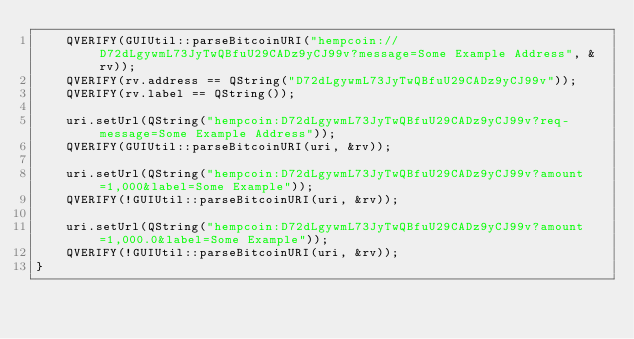Convert code to text. <code><loc_0><loc_0><loc_500><loc_500><_C++_>    QVERIFY(GUIUtil::parseBitcoinURI("hempcoin://D72dLgywmL73JyTwQBfuU29CADz9yCJ99v?message=Some Example Address", &rv));
    QVERIFY(rv.address == QString("D72dLgywmL73JyTwQBfuU29CADz9yCJ99v"));
    QVERIFY(rv.label == QString());

    uri.setUrl(QString("hempcoin:D72dLgywmL73JyTwQBfuU29CADz9yCJ99v?req-message=Some Example Address"));
    QVERIFY(GUIUtil::parseBitcoinURI(uri, &rv));

    uri.setUrl(QString("hempcoin:D72dLgywmL73JyTwQBfuU29CADz9yCJ99v?amount=1,000&label=Some Example"));
    QVERIFY(!GUIUtil::parseBitcoinURI(uri, &rv));

    uri.setUrl(QString("hempcoin:D72dLgywmL73JyTwQBfuU29CADz9yCJ99v?amount=1,000.0&label=Some Example"));
    QVERIFY(!GUIUtil::parseBitcoinURI(uri, &rv));
}
</code> 